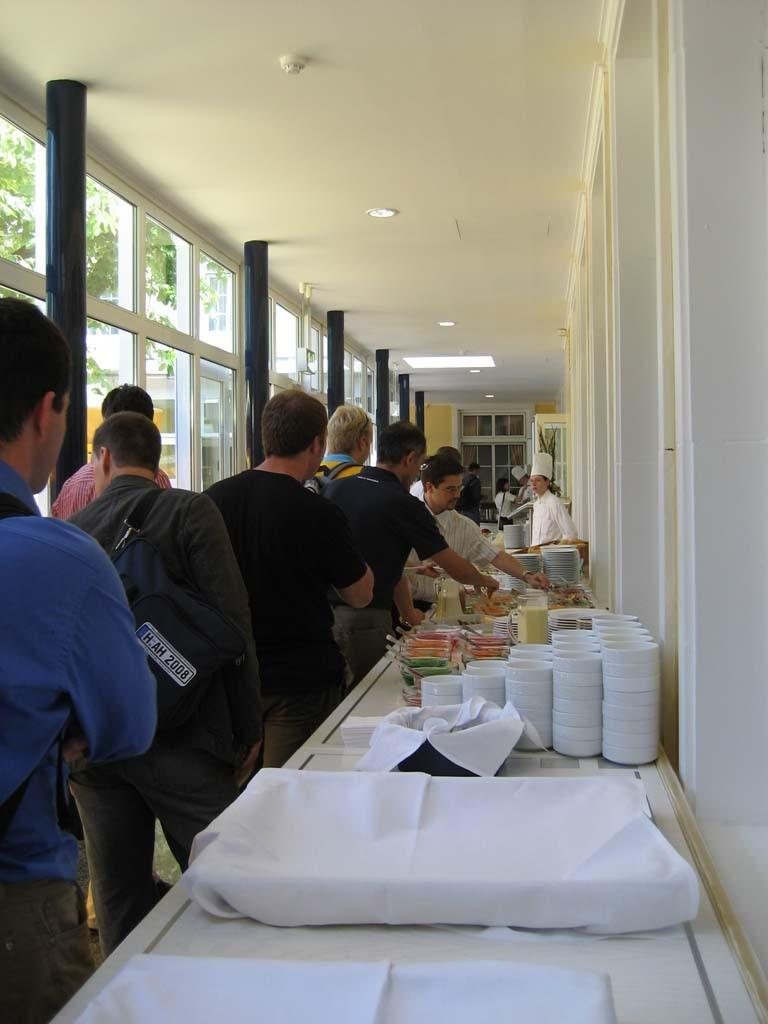What are the people in the image doing? The people in the image are standing in a line. What objects are on the table in the image? There are cups, bowls, and plates on the table in the image. Can you describe the man in the image? There is a man standing in the image. What type of competition is taking place on the sidewalk in the image? There is no competition or sidewalk present in the image; it features people standing in a line and objects on a table. How many birds can be seen flying in the image? There are no birds visible in the image. 